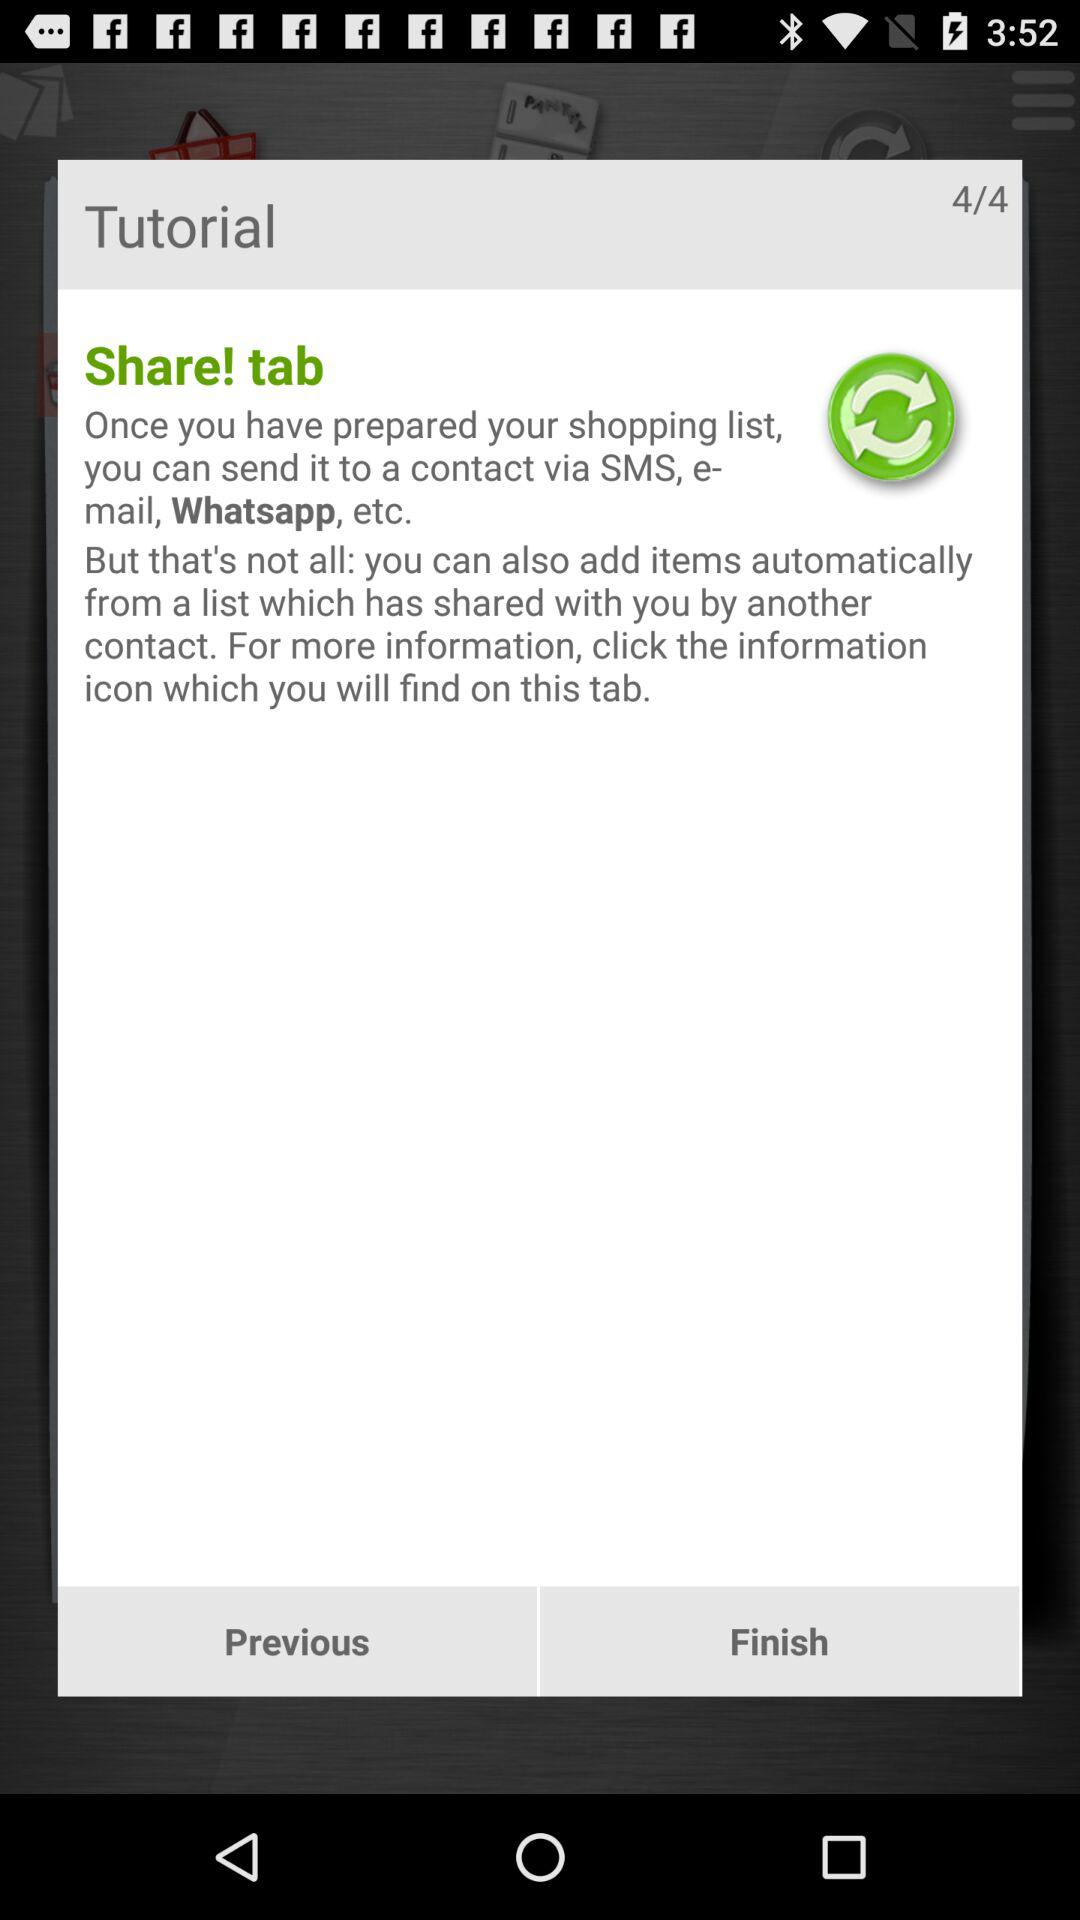How many total pages are there? The total pages are 4. 